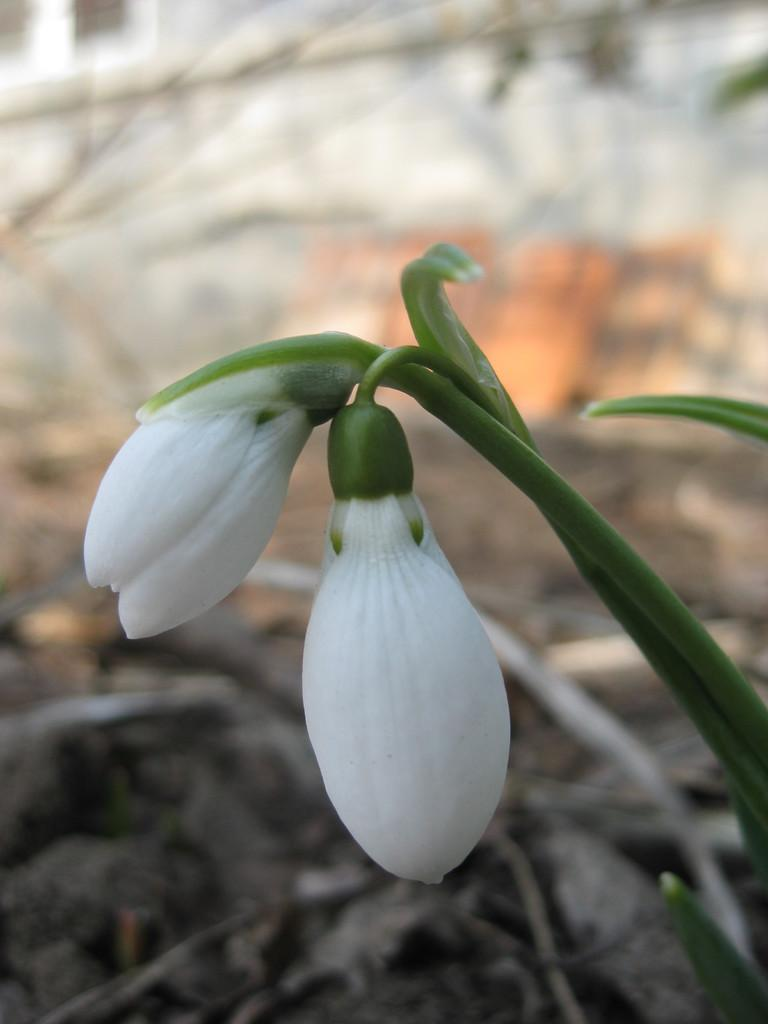What type of plant is in the image? There is a small plant in the image. What stage of growth are the flowers on the plant? The plant has two flower buds. What color are the flower buds? The flower buds are white in color. Can you describe the background of the image? There are dried twigs behind the plant, but they are not clearly visible. What is the purpose of the camp in the image? There is no camp present in the image; it features a small plant with white flower buds and a background of dried twigs. 